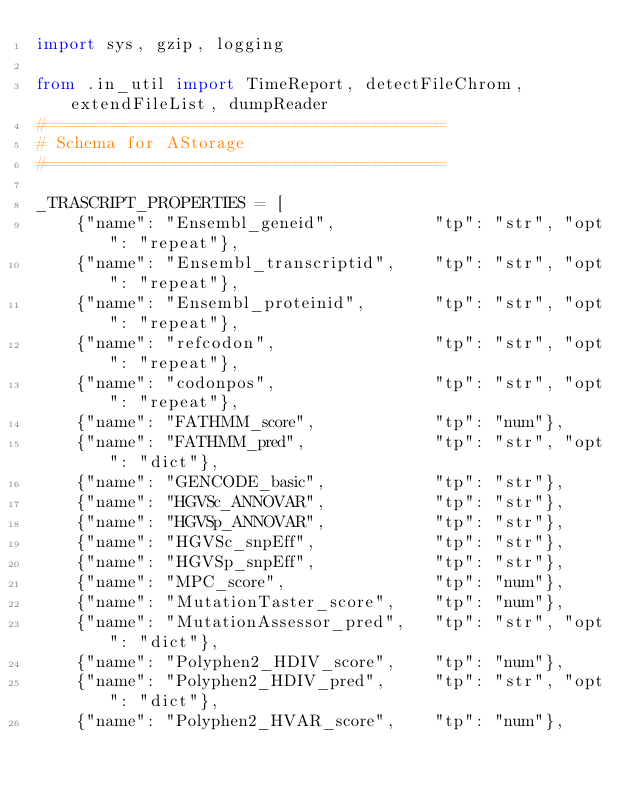Convert code to text. <code><loc_0><loc_0><loc_500><loc_500><_Python_>import sys, gzip, logging

from .in_util import TimeReport, detectFileChrom, extendFileList, dumpReader
#========================================
# Schema for AStorage
#========================================

_TRASCRIPT_PROPERTIES = [
    {"name": "Ensembl_geneid",          "tp": "str", "opt": "repeat"},
    {"name": "Ensembl_transcriptid",    "tp": "str", "opt": "repeat"},
    {"name": "Ensembl_proteinid",       "tp": "str", "opt": "repeat"},
    {"name": "refcodon",                "tp": "str", "opt": "repeat"},
    {"name": "codonpos",                "tp": "str", "opt": "repeat"},
    {"name": "FATHMM_score",            "tp": "num"},
    {"name": "FATHMM_pred",             "tp": "str", "opt": "dict"},
    {"name": "GENCODE_basic",           "tp": "str"},
    {"name": "HGVSc_ANNOVAR",           "tp": "str"},
    {"name": "HGVSp_ANNOVAR",           "tp": "str"},
    {"name": "HGVSc_snpEff",            "tp": "str"},
    {"name": "HGVSp_snpEff",            "tp": "str"},
    {"name": "MPC_score",               "tp": "num"},
    {"name": "MutationTaster_score",    "tp": "num"},
    {"name": "MutationAssessor_pred",   "tp": "str", "opt": "dict"},
    {"name": "Polyphen2_HDIV_score",    "tp": "num"},
    {"name": "Polyphen2_HDIV_pred",     "tp": "str", "opt": "dict"},
    {"name": "Polyphen2_HVAR_score",    "tp": "num"},</code> 